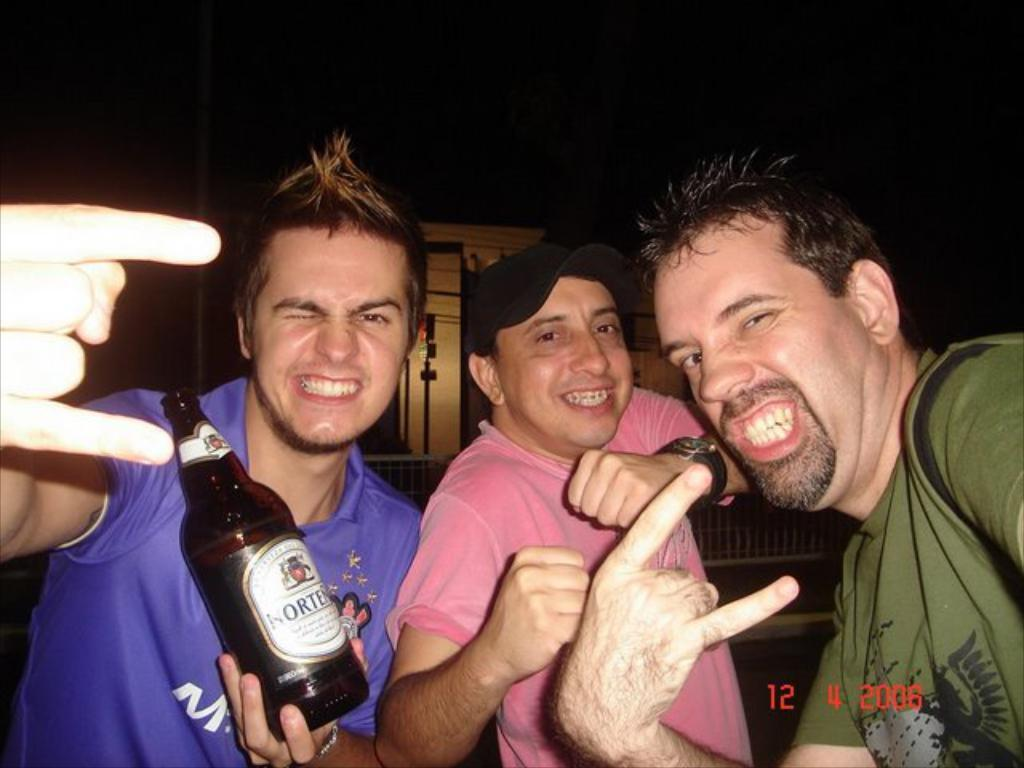What are the people in the picture doing? The people in the picture are giving a pose. What type of plants can be seen growing in the zoo in the image? There is no reference to plants, a zoo, or any growth in the image; it simply shows people giving a pose. 